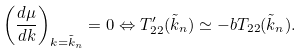<formula> <loc_0><loc_0><loc_500><loc_500>\left ( \frac { d \mu } { d k } \right ) _ { k = \tilde { k } _ { n } } = 0 \Leftrightarrow T _ { 2 2 } ^ { \prime } ( \tilde { k } _ { n } ) \simeq - b T _ { 2 2 } ( \tilde { k } _ { n } ) .</formula> 